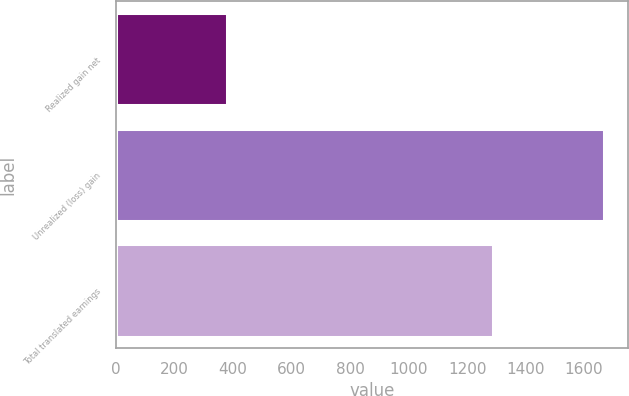Convert chart. <chart><loc_0><loc_0><loc_500><loc_500><bar_chart><fcel>Realized gain net<fcel>Unrealized (loss) gain<fcel>Total translated earnings<nl><fcel>379<fcel>1668<fcel>1289<nl></chart> 